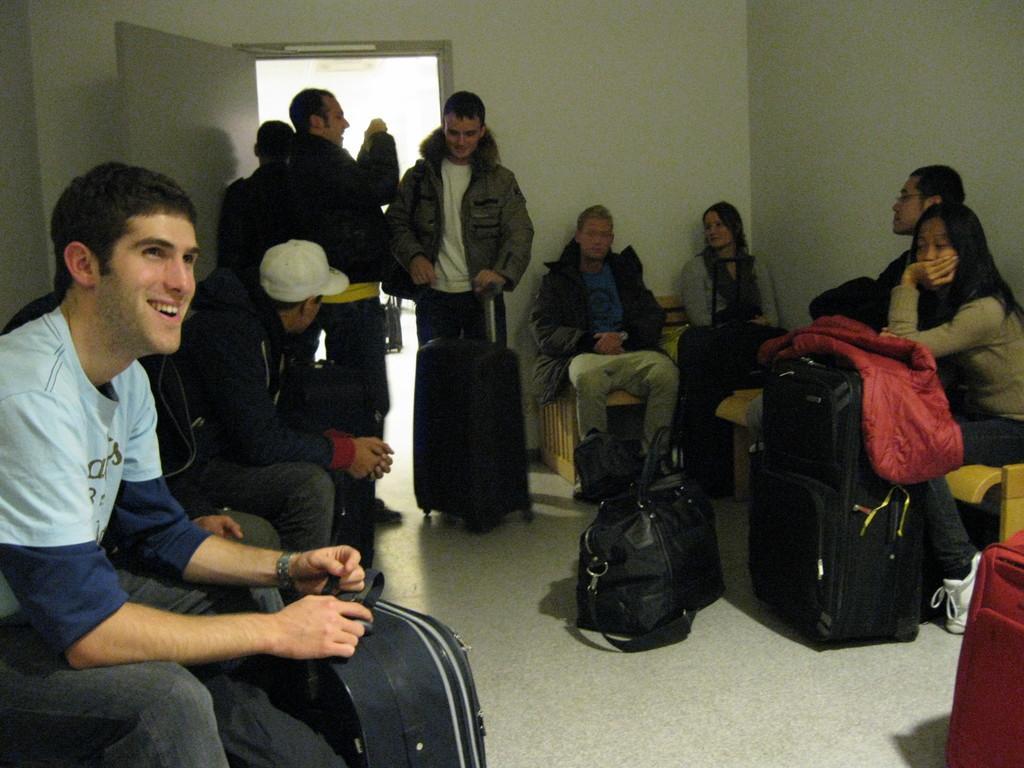Describe this image in one or two sentences. This is the picture of a group of people sitting and someone standing with their luggage. 